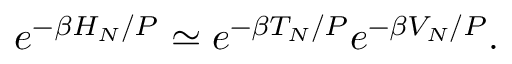<formula> <loc_0><loc_0><loc_500><loc_500>e ^ { - \beta H _ { N } / P } \simeq e ^ { - \beta T _ { N } / P } e ^ { - \beta V _ { N } / P } .</formula> 